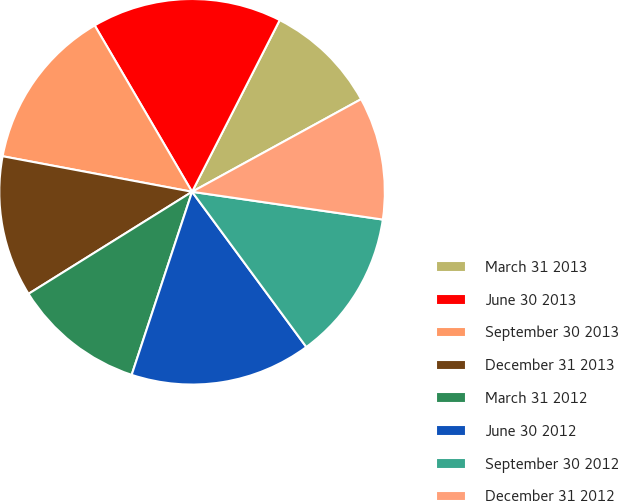<chart> <loc_0><loc_0><loc_500><loc_500><pie_chart><fcel>March 31 2013<fcel>June 30 2013<fcel>September 30 2013<fcel>December 31 2013<fcel>March 31 2012<fcel>June 30 2012<fcel>September 30 2012<fcel>December 31 2012<nl><fcel>9.51%<fcel>15.94%<fcel>13.62%<fcel>11.83%<fcel>11.05%<fcel>15.17%<fcel>12.6%<fcel>10.28%<nl></chart> 